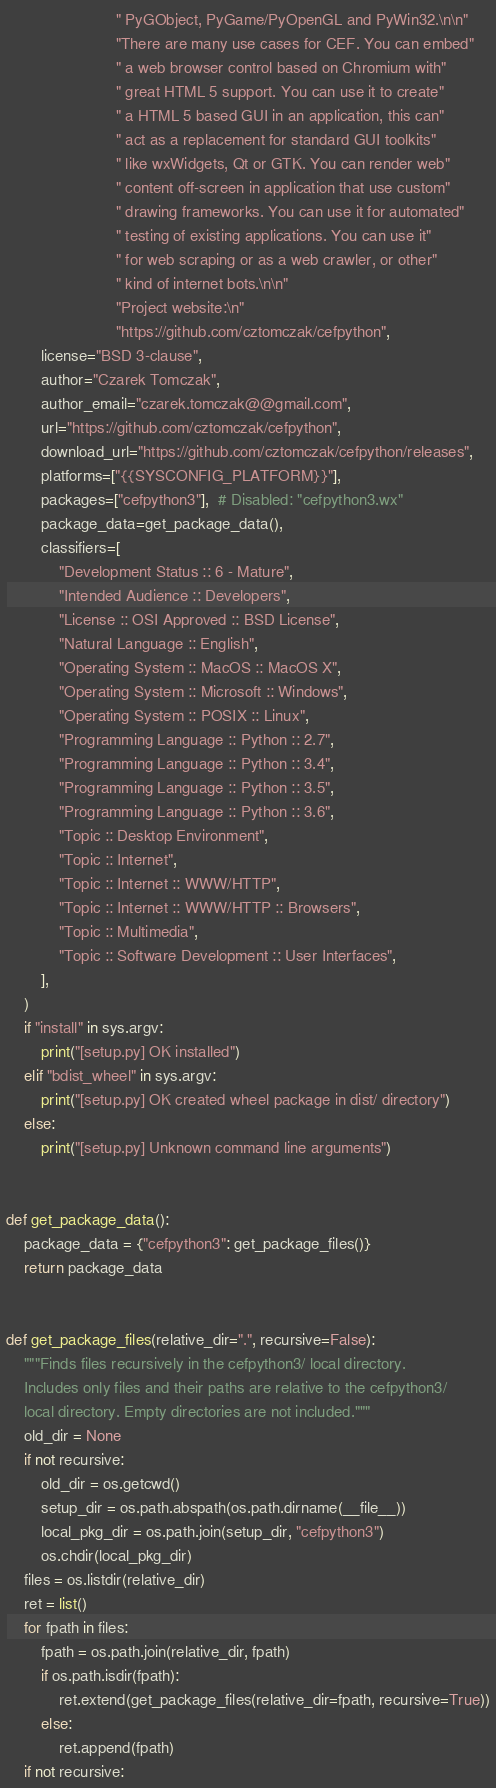<code> <loc_0><loc_0><loc_500><loc_500><_Python_>                         " PyGObject, PyGame/PyOpenGL and PyWin32.\n\n"
                         "There are many use cases for CEF. You can embed"
                         " a web browser control based on Chromium with"
                         " great HTML 5 support. You can use it to create"
                         " a HTML 5 based GUI in an application, this can"
                         " act as a replacement for standard GUI toolkits"
                         " like wxWidgets, Qt or GTK. You can render web"
                         " content off-screen in application that use custom"
                         " drawing frameworks. You can use it for automated"
                         " testing of existing applications. You can use it"
                         " for web scraping or as a web crawler, or other"
                         " kind of internet bots.\n\n"
                         "Project website:\n"
                         "https://github.com/cztomczak/cefpython",
        license="BSD 3-clause",
        author="Czarek Tomczak",
        author_email="czarek.tomczak@@gmail.com",
        url="https://github.com/cztomczak/cefpython",
        download_url="https://github.com/cztomczak/cefpython/releases",
        platforms=["{{SYSCONFIG_PLATFORM}}"],
        packages=["cefpython3"],  # Disabled: "cefpython3.wx"
        package_data=get_package_data(),
        classifiers=[
            "Development Status :: 6 - Mature",
            "Intended Audience :: Developers",
            "License :: OSI Approved :: BSD License",
            "Natural Language :: English",
            "Operating System :: MacOS :: MacOS X",
            "Operating System :: Microsoft :: Windows",
            "Operating System :: POSIX :: Linux",
            "Programming Language :: Python :: 2.7",
            "Programming Language :: Python :: 3.4",
            "Programming Language :: Python :: 3.5",
            "Programming Language :: Python :: 3.6",
            "Topic :: Desktop Environment",
            "Topic :: Internet",
            "Topic :: Internet :: WWW/HTTP",
            "Topic :: Internet :: WWW/HTTP :: Browsers",
            "Topic :: Multimedia",
            "Topic :: Software Development :: User Interfaces",
        ],
    )
    if "install" in sys.argv:
        print("[setup.py] OK installed")
    elif "bdist_wheel" in sys.argv:
        print("[setup.py] OK created wheel package in dist/ directory")
    else:
        print("[setup.py] Unknown command line arguments")


def get_package_data():
    package_data = {"cefpython3": get_package_files()}
    return package_data


def get_package_files(relative_dir=".", recursive=False):
    """Finds files recursively in the cefpython3/ local directory.
    Includes only files and their paths are relative to the cefpython3/
    local directory. Empty directories are not included."""
    old_dir = None
    if not recursive:
        old_dir = os.getcwd()
        setup_dir = os.path.abspath(os.path.dirname(__file__))
        local_pkg_dir = os.path.join(setup_dir, "cefpython3")
        os.chdir(local_pkg_dir)
    files = os.listdir(relative_dir)
    ret = list()
    for fpath in files:
        fpath = os.path.join(relative_dir, fpath)
        if os.path.isdir(fpath):
            ret.extend(get_package_files(relative_dir=fpath, recursive=True))
        else:
            ret.append(fpath)
    if not recursive:</code> 